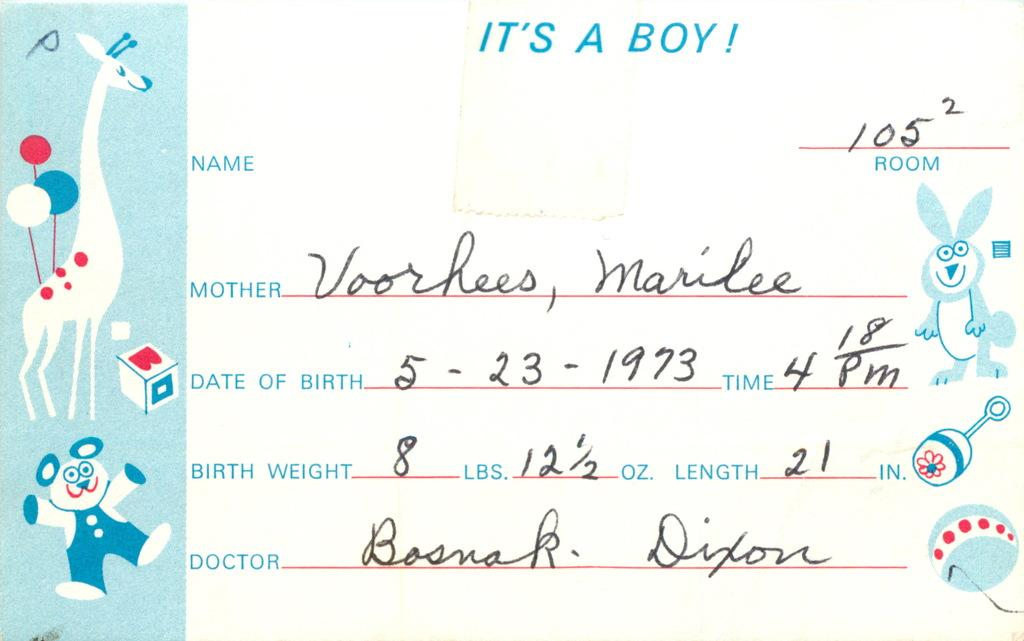What is present on the paper in the image? There is text, numbers, drawings of a doll, and drawings of animals on the paper. Can you describe the type of text written on the paper? The provided facts do not specify the type of text written on the paper. What kind of animals are depicted in the drawings on the paper? The provided facts do not specify the type of animals depicted in the drawings on the paper. What type of stocking is the doll wearing in the image? There is no doll wearing a stocking in the image, as the doll is depicted in a drawing on the paper. Is the paper a work of fiction or non-fiction? The provided facts do not specify whether the paper is a work of fiction or non-fiction. 